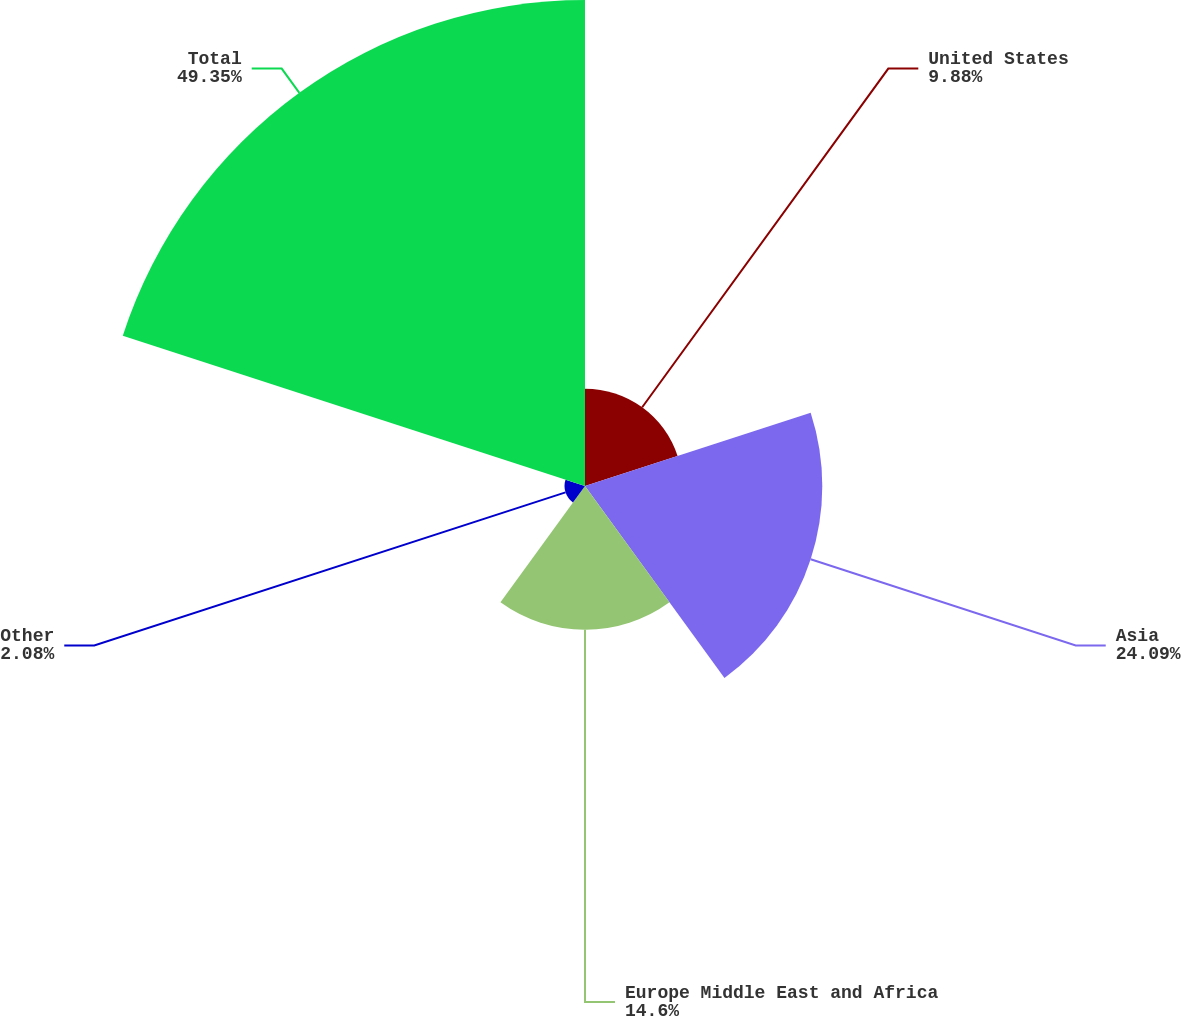Convert chart to OTSL. <chart><loc_0><loc_0><loc_500><loc_500><pie_chart><fcel>United States<fcel>Asia<fcel>Europe Middle East and Africa<fcel>Other<fcel>Total<nl><fcel>9.88%<fcel>24.09%<fcel>14.6%<fcel>2.08%<fcel>49.34%<nl></chart> 